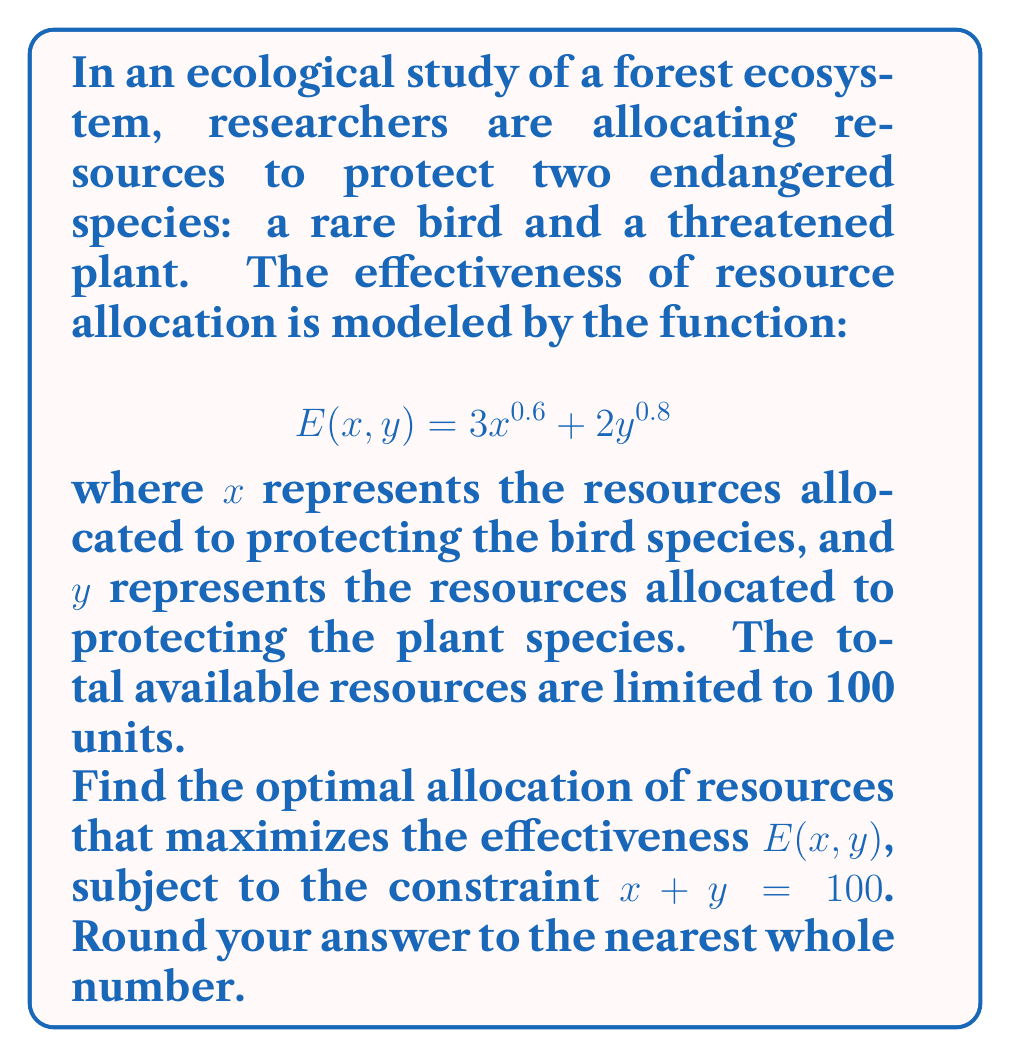Show me your answer to this math problem. To solve this constrained optimization problem, we'll use the method of Lagrange multipliers:

1) First, we form the Lagrangian function:
   $$L(x, y, \lambda) = 3x^{0.6} + 2y^{0.8} - \lambda(x + y - 100)$$

2) Next, we take partial derivatives and set them equal to zero:
   $$\frac{\partial L}{\partial x} = 1.8x^{-0.4} - \lambda = 0$$
   $$\frac{\partial L}{\partial y} = 1.6y^{-0.2} - \lambda = 0$$
   $$\frac{\partial L}{\partial \lambda} = x + y - 100 = 0$$

3) From the first two equations:
   $$1.8x^{-0.4} = 1.6y^{-0.2}$$

4) Rearranging:
   $$y^{-0.2} = \frac{1.8}{1.6}x^{-0.4}$$
   $$y = (\frac{1.8}{1.6})^5 x^2 \approx 1.5625x^2$$

5) Substituting into the constraint equation:
   $$x + 1.5625x^2 = 100$$

6) Solving this quadratic equation:
   $$1.5625x^2 + x - 100 = 0$$
   $$x \approx 62.4$$

7) Substituting back:
   $$y = 100 - 62.4 = 37.6$$

8) Rounding to the nearest whole number:
   $$x = 62, y = 38$$
Answer: The optimal allocation of resources is approximately 62 units for the bird species and 38 units for the plant species. 